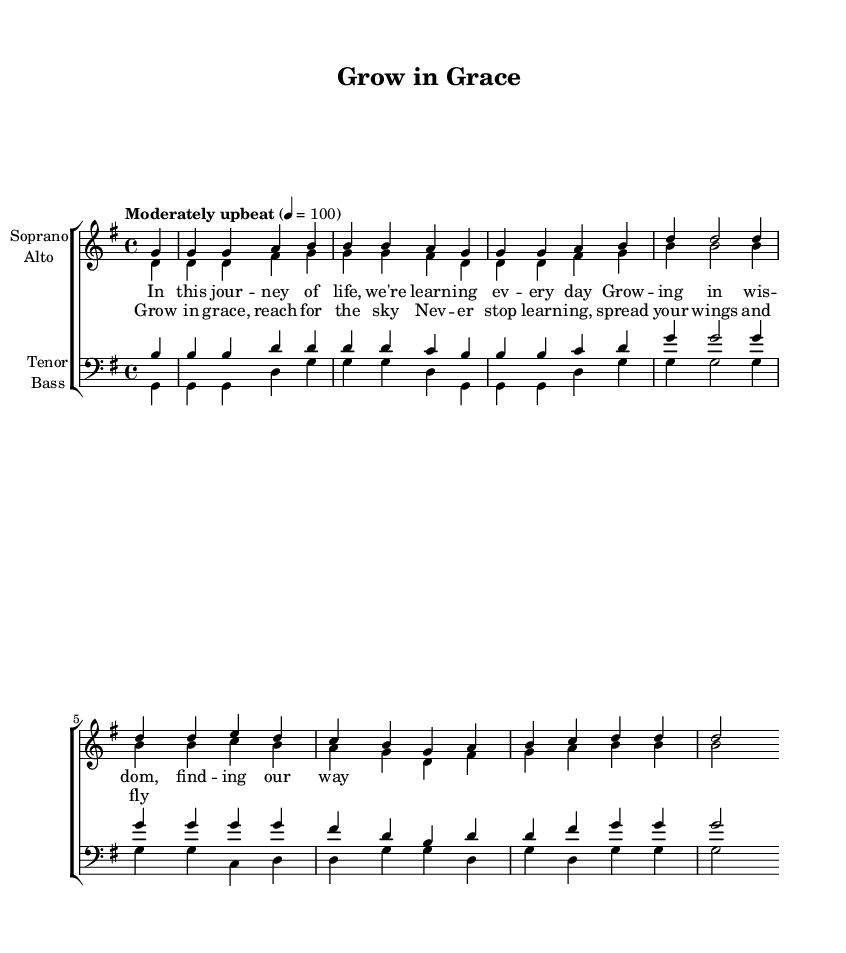What is the key signature of this music? The key signature is G major, which has one sharp (F#). You can determine the key signature from the global section at the top, where it indicates "\key g \major".
Answer: G major What is the time signature of this music? The time signature is 4/4, meaning there are four beats in each measure and a quarter note gets one beat. This is also mentioned in the global section where it states "\time 4/4".
Answer: 4/4 What is the tempo marking indicated in the sheet music? The tempo marking is "Moderately upbeat" at a speed of 100 beats per minute. This is specified in the global section with "\tempo 'Moderately upbeat' 4 = 100".
Answer: Moderately upbeat How many measures are there in the soprano part? To find this, you count the number of bar lines in the soprano part. In the provided music, there are 5 measures visible in the soprano line.
Answer: 5 What is the main theme conveyed through the lyrics of the chorus? The main theme of the chorus is about personal growth and striving to reach one's potential, specifically focusing on learning and taking flight. This can be inferred from the repeated phrases in the chorus lyrics.
Answer: Personal growth Which voices are included in this choir piece? The choir piece includes Soprano, Alto, Tenor, and Bass. This is shown at the beginning where the voices are listed under each staff.
Answer: Soprano, Alto, Tenor, Bass What is the mood conveyed by the expression "Grow in grace, reach for the sky"? The mood conveyed is one of encouragement and empowerment, showing a positive outlook toward personal development and aspirations. This can be inferred from the uplifting language used in the lyrics.
Answer: Encouragement 